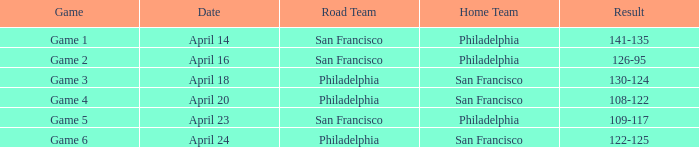On what date was game 2 played? April 16. I'm looking to parse the entire table for insights. Could you assist me with that? {'header': ['Game', 'Date', 'Road Team', 'Home Team', 'Result'], 'rows': [['Game 1', 'April 14', 'San Francisco', 'Philadelphia', '141-135'], ['Game 2', 'April 16', 'San Francisco', 'Philadelphia', '126-95'], ['Game 3', 'April 18', 'Philadelphia', 'San Francisco', '130-124'], ['Game 4', 'April 20', 'Philadelphia', 'San Francisco', '108-122'], ['Game 5', 'April 23', 'San Francisco', 'Philadelphia', '109-117'], ['Game 6', 'April 24', 'Philadelphia', 'San Francisco', '122-125']]} 